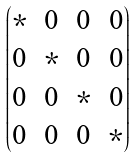Convert formula to latex. <formula><loc_0><loc_0><loc_500><loc_500>\begin{pmatrix} \ast & 0 & 0 & 0 \\ 0 & \ast & 0 & 0 \\ 0 & 0 & \ast & 0 \\ 0 & 0 & 0 & \ast \end{pmatrix}</formula> 